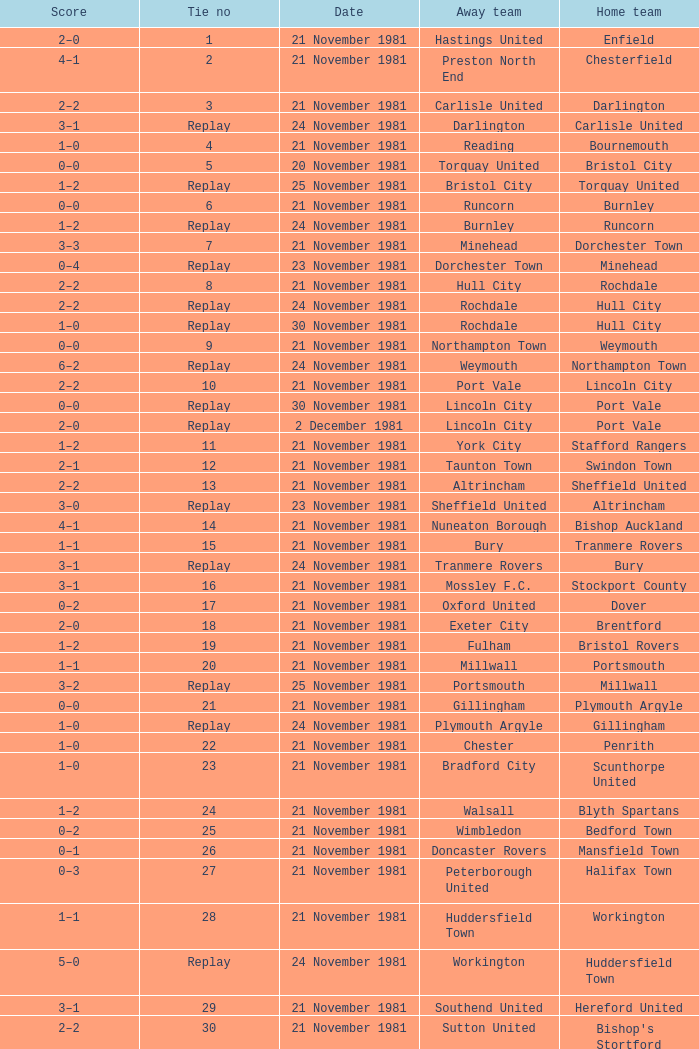Minehead has what tie number? Replay. 